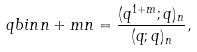Convert formula to latex. <formula><loc_0><loc_0><loc_500><loc_500>\ q b i n { n + m } { n } = \frac { ( q ^ { 1 + m } ; q ) _ { n } } { ( q ; q ) _ { n } } ,</formula> 